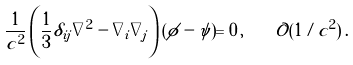Convert formula to latex. <formula><loc_0><loc_0><loc_500><loc_500>\frac { 1 } { c ^ { 2 } } \left ( \frac { 1 } { 3 } \delta _ { i j } \nabla ^ { 2 } - \nabla _ { i } \nabla _ { j } \right ) ( \phi - \psi ) = 0 \, , \quad \mathcal { O } ( 1 / c ^ { 2 } ) \, .</formula> 